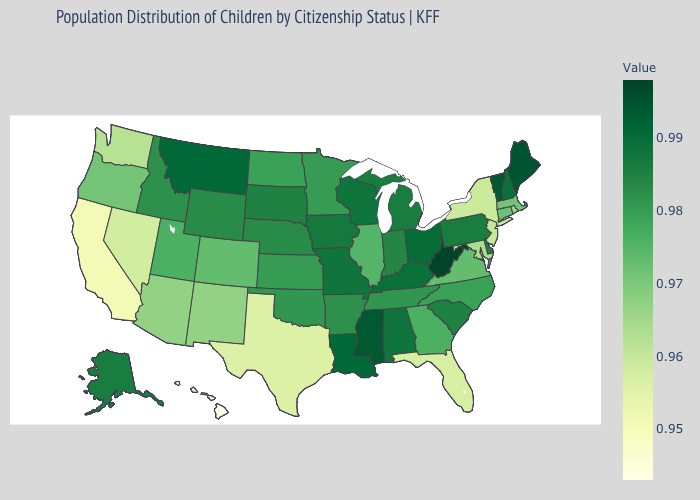Which states have the lowest value in the West?
Be succinct. Hawaii. Which states have the highest value in the USA?
Be succinct. West Virginia. Among the states that border Indiana , does Kentucky have the lowest value?
Short answer required. No. Which states hav the highest value in the South?
Concise answer only. West Virginia. Among the states that border New Hampshire , which have the lowest value?
Short answer required. Massachusetts. Does Arkansas have the lowest value in the USA?
Quick response, please. No. Does South Dakota have the lowest value in the MidWest?
Write a very short answer. No. 